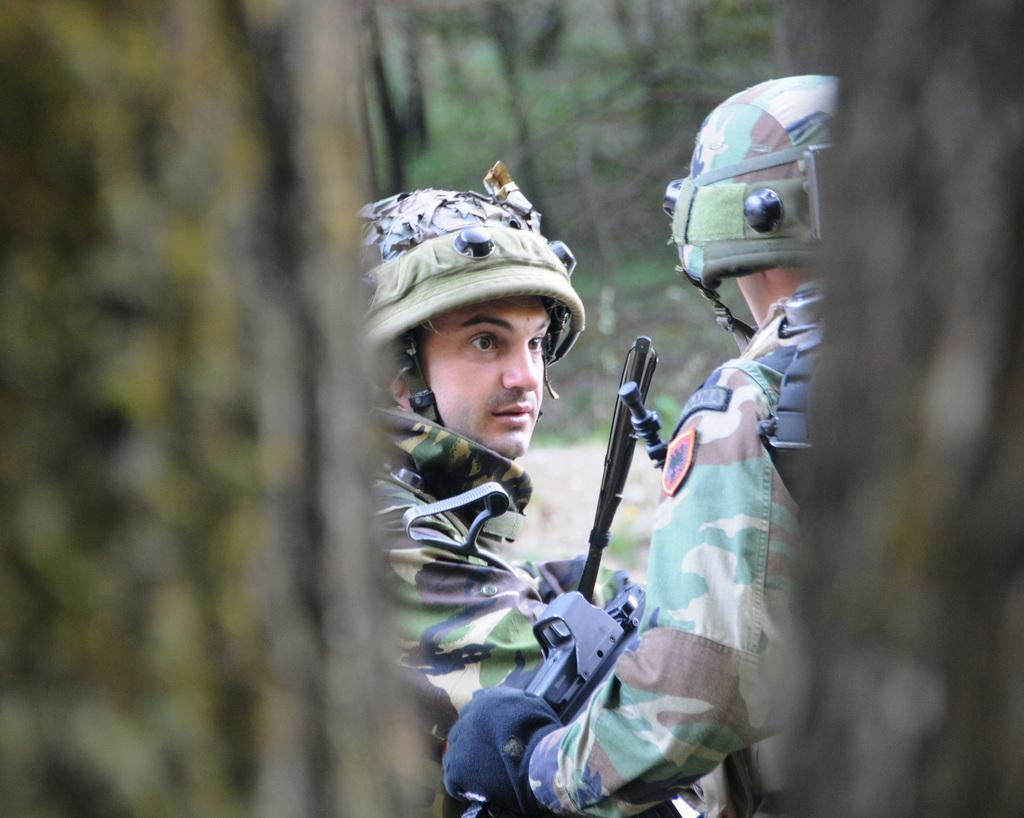How many people are in the image? There are two persons in the image. What are the persons wearing? The persons are wearing military uniforms. What else can be seen in the image besides the people? Weapons and trees are present in the image. Are there any parts of the image that are not clear? Yes, some parts of the image are blurred. What type of agreement can be seen between the two persons in the image? There is no agreement visible in the image; it only shows two persons wearing military uniforms and other objects. What does the image smell like? The image is a visual representation and does not have a smell. 